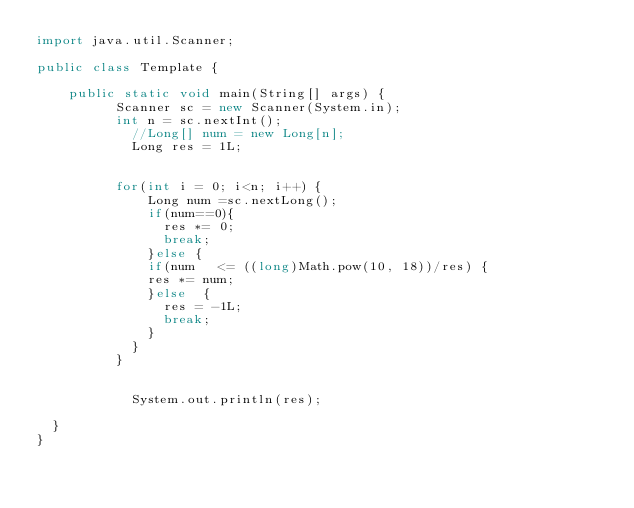Convert code to text. <code><loc_0><loc_0><loc_500><loc_500><_Java_>import java.util.Scanner;

public class Template {

		public static void main(String[] args) {
	        Scanner sc = new Scanner(System.in);
	        int n = sc.nextInt();
            //Long[] num = new Long[n];
            Long res = 1L;
            
            
	        for(int i = 0; i<n; i++) {
              Long num =sc.nextLong();
              if(num==0){
            	  res *= 0;
            	  break;
              }else {
              if(num   <= ((long)Math.pow(10, 18))/res) {
            	res *= num;
              }else  {
            	  res = -1L;
            	  break;
              }
            }
	        }
          
	        
            System.out.println(res); 
	        
	}
}

</code> 